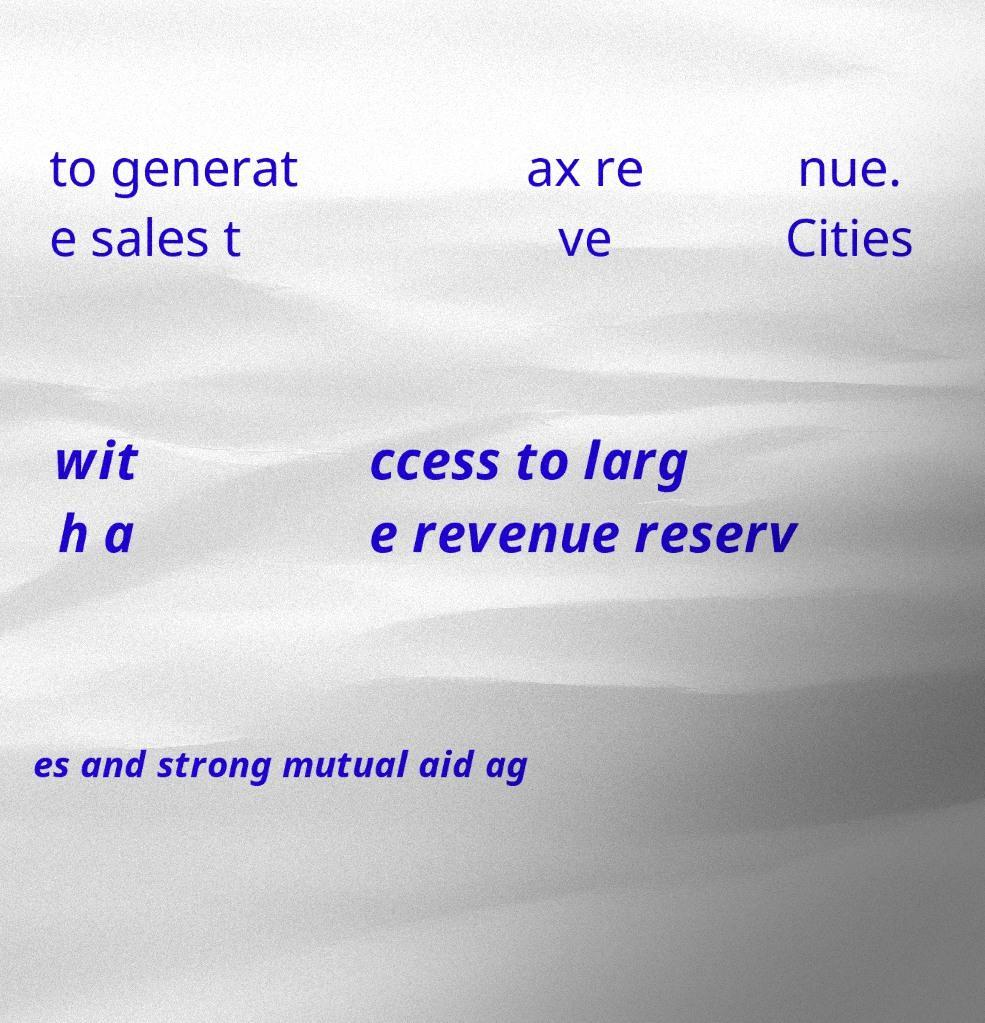Can you read and provide the text displayed in the image?This photo seems to have some interesting text. Can you extract and type it out for me? to generat e sales t ax re ve nue. Cities wit h a ccess to larg e revenue reserv es and strong mutual aid ag 